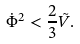Convert formula to latex. <formula><loc_0><loc_0><loc_500><loc_500>\dot { \Phi } ^ { 2 } < \frac { 2 } { 3 } \tilde { V } .</formula> 